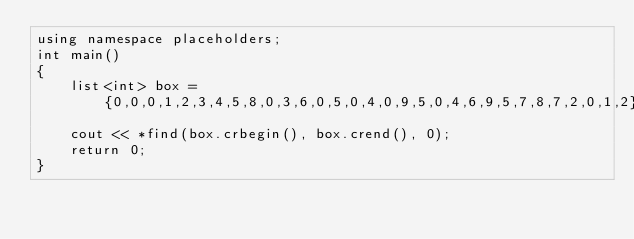<code> <loc_0><loc_0><loc_500><loc_500><_C++_>using namespace placeholders;
int main()
{
    list<int> box = {0,0,0,1,2,3,4,5,8,0,3,6,0,5,0,4,0,9,5,0,4,6,9,5,7,8,7,2,0,1,2};
    cout << *find(box.crbegin(), box.crend(), 0);
    return 0;
}

</code> 